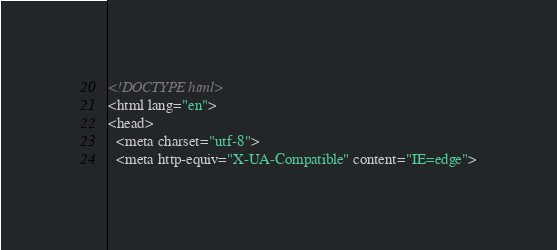Convert code to text. <code><loc_0><loc_0><loc_500><loc_500><_HTML_><!DOCTYPE html>
<html lang="en">
<head>
  <meta charset="utf-8">
  <meta http-equiv="X-UA-Compatible" content="IE=edge"></code> 